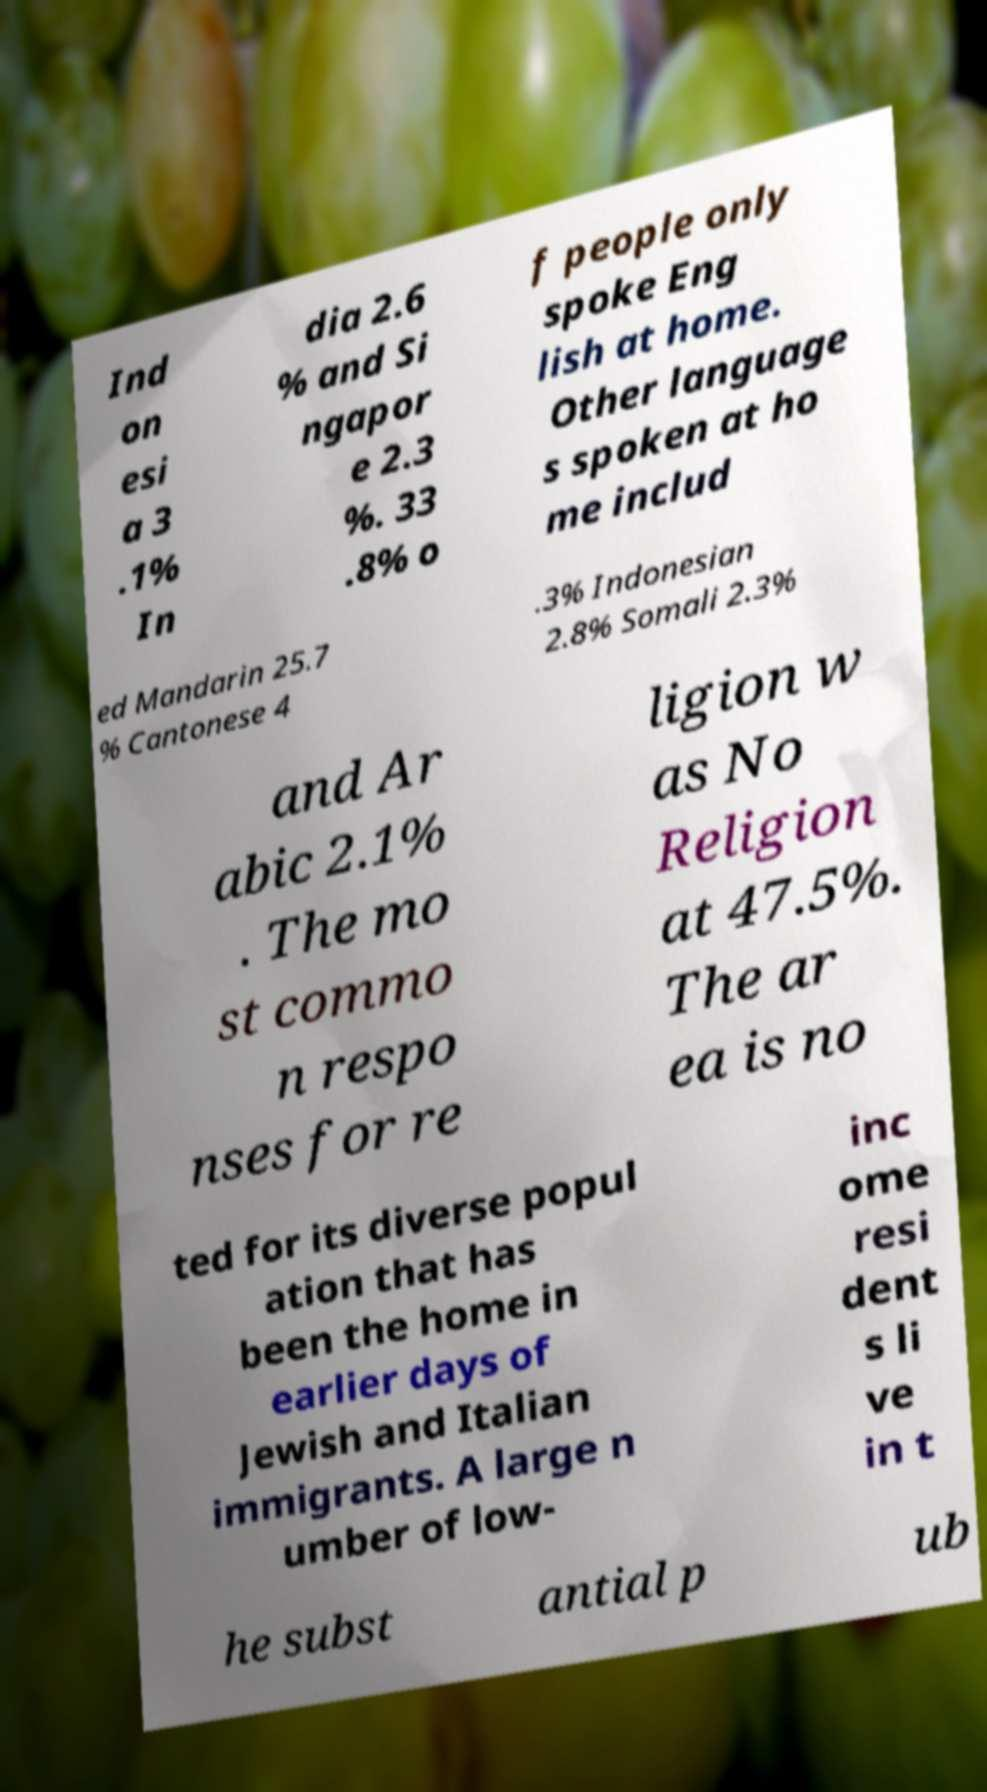Please read and relay the text visible in this image. What does it say? Ind on esi a 3 .1% In dia 2.6 % and Si ngapor e 2.3 %. 33 .8% o f people only spoke Eng lish at home. Other language s spoken at ho me includ ed Mandarin 25.7 % Cantonese 4 .3% Indonesian 2.8% Somali 2.3% and Ar abic 2.1% . The mo st commo n respo nses for re ligion w as No Religion at 47.5%. The ar ea is no ted for its diverse popul ation that has been the home in earlier days of Jewish and Italian immigrants. A large n umber of low- inc ome resi dent s li ve in t he subst antial p ub 